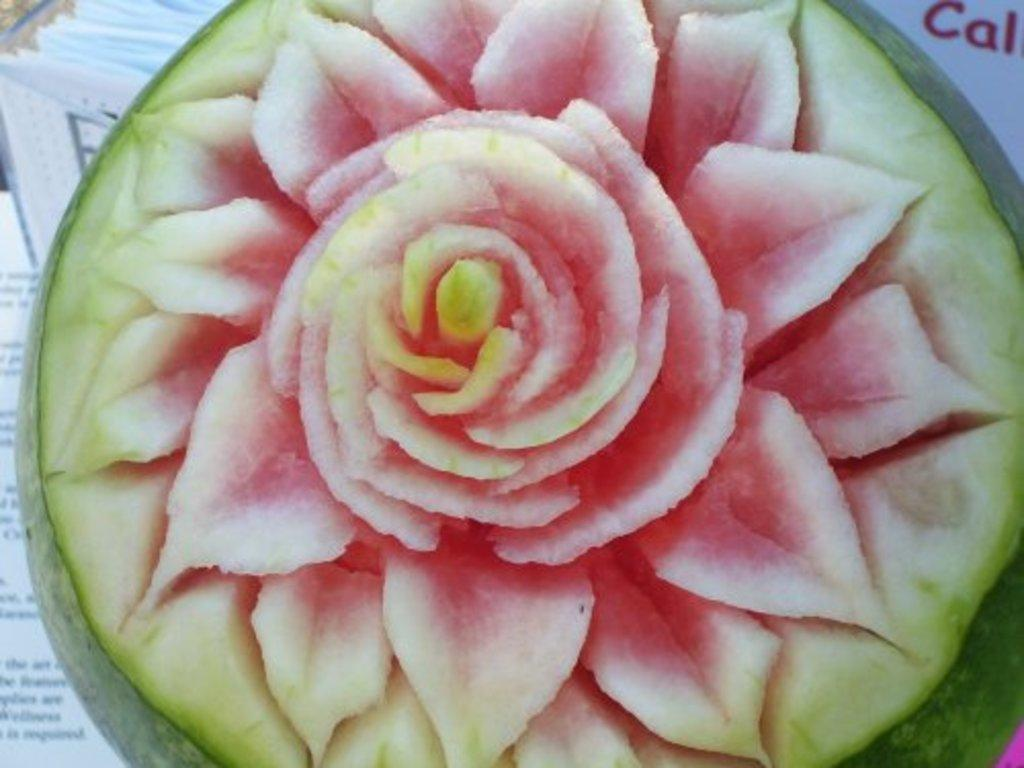What is the main subject of the image? The main subject of the image is a watermelon with a flower design. Can you describe the design on the watermelon? The watermelon has a flower design on it. What else can be seen in the image besides the watermelon? In the background on the left side of the image, there are papers and an object. What is the chance of finding a grip on the watermelon in the image? There is no grip present on the watermelon in the image, so it cannot be found. 